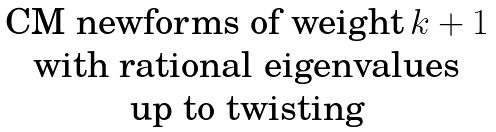<formula> <loc_0><loc_0><loc_500><loc_500>\begin{matrix} \text {CM newforms of weight} \, k + 1 \\ \text {with rational eigenvalues} \\ \text {up to twisting} \end{matrix}</formula> 